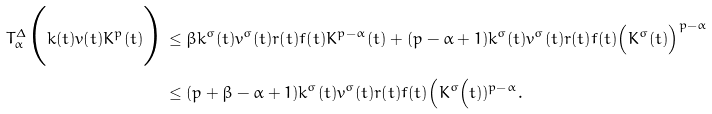Convert formula to latex. <formula><loc_0><loc_0><loc_500><loc_500>T ^ { \Delta } _ { \alpha } \Big ( k ( t ) v ( t ) K ^ { p } ( t ) \Big ) & \leq \beta k ^ { \sigma } ( t ) v ^ { \sigma } ( t ) r ( t ) f ( t ) K ^ { p - \alpha } ( t ) + ( p - \alpha + 1 ) k ^ { \sigma } ( t ) v ^ { \sigma } ( t ) r ( t ) f ( t ) \Big ( K ^ { \sigma } ( t ) \Big ) ^ { p - \alpha } \\ & \leq ( p + \beta - \alpha + 1 ) k ^ { \sigma } ( t ) v ^ { \sigma } ( t ) r ( t ) f ( t ) \Big ( K ^ { \sigma } \Big ( t ) ) ^ { p - \alpha } .</formula> 